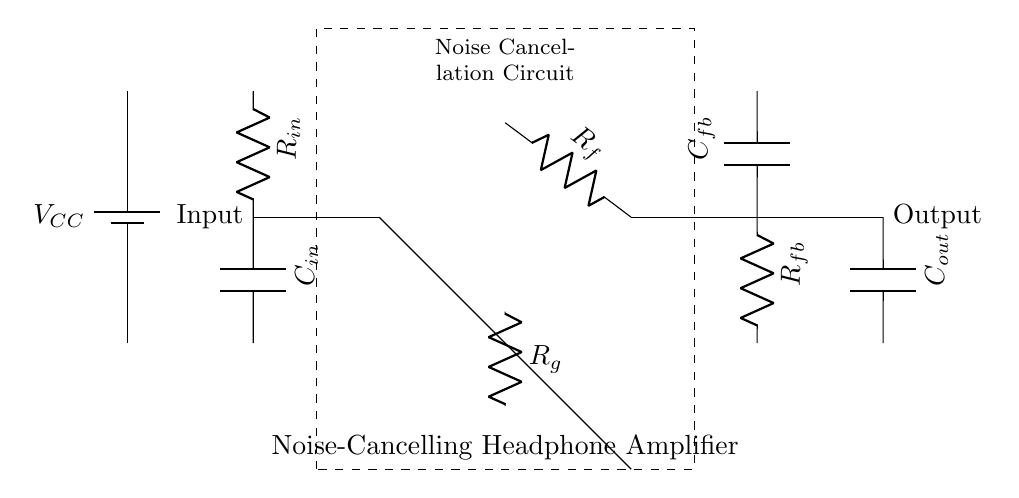What type of amplifier is used in this circuit? The circuit contains an operational amplifier, which is indicated by the symbol shown in the diagram. This type of amplifier is commonly used for signal processing, including amplification in noise-canceling circuits.
Answer: Operational amplifier What component is used for noise cancellation? The circuit includes a dashed rectangle labeled as the "Noise Cancellation Circuit," which indicates that it has a designated section for noise reduction components and functionality.
Answer: Noise cancellation circuit What is the function of the capacitor labeled C_out? Capacitor C_out serves as an output capacitor in the circuit, typically smoothing or coupling signals to headphones, ensuring that the output is audio-frequency compatible with headphones.
Answer: Output coupling What is the value of the feedback resistor R_f? The diagram does not specify an exact numerical value for the feedback resistor R_f, but it is labeled with a reference, indicating its function as part of the feedback network in the amplifier stage.
Answer: Not specified How many resistors are present in the circuit? By counting the number of resistor symbols displayed in the circuit diagram, there are three resistors visible: R_in, R_f, and R_g. Each plays a specific role in the function of the amplifier.
Answer: Three Which component helps to filter the input signal? The capacitor labeled C_in is positioned at the input stage of the circuit, where it typically serves to filter or couple the incoming audio signal, blocking DC components and allowing AC signals to pass.
Answer: Capacitor Where does the power supply voltage V_CC connect? The power supply voltage V_CC connects to the operational amplifier, providing the necessary high power level for its operation, as indicated by its connection to the top of the amplifier stage in the diagram.
Answer: To the operational amplifier 